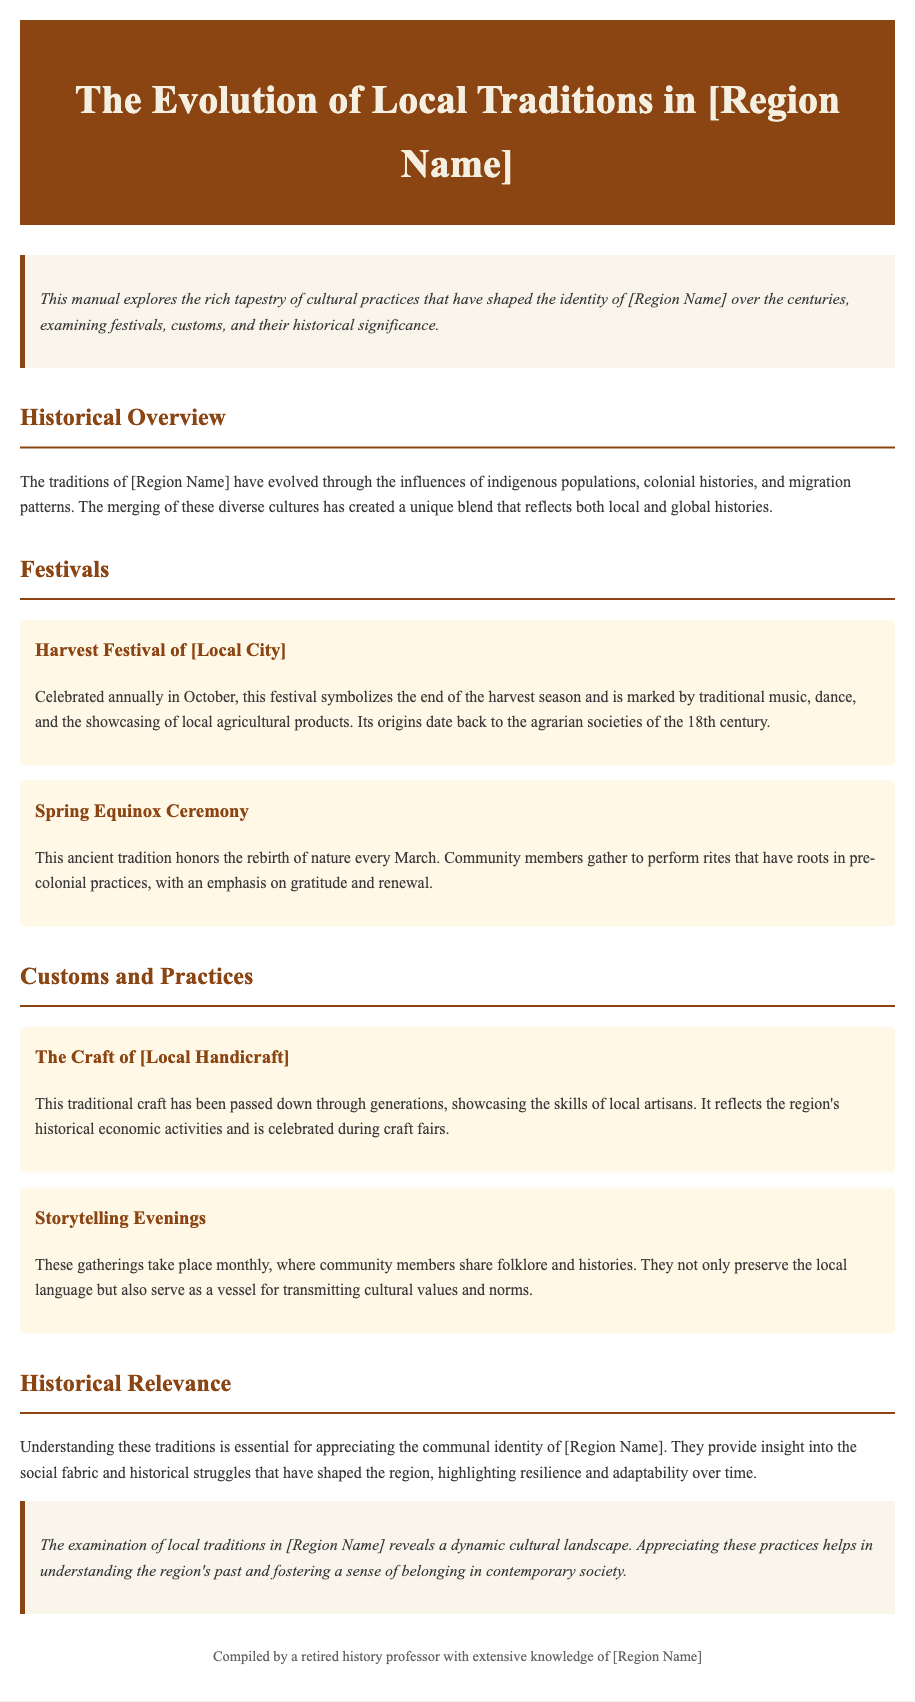What is the title of the manual? The title of the manual is found in the header section, which presents the main topic of discussion.
Answer: The Evolution of Local Traditions in [Region Name] What month is the Harvest Festival celebrated? The manual specifies that this festival takes place annually in October.
Answer: October What is the purpose of the Spring Equinox Ceremony? This ceremony has roots in pre-colonial practices and emphasizes gratitude and renewal.
Answer: Gratitude and renewal How often do Storytelling Evenings occur? The document states that these gatherings take place monthly, indicating their regularity.
Answer: Monthly What does the craft highlighted in the customs represent? The craft showcases the skills of local artisans and reflects the region's historical economic activities.
Answer: Historical economic activities What type of gatherings are mentioned in the customs section? These gatherings are aimed at preserving local folklore and transmitting cultural values and norms.
Answer: Storytelling Evenings What emphasis is placed on community in the historical relevance section? The traditions provide insight into the social fabric and historical struggles that have shaped the region, highlighting certain qualities.
Answer: Resilience and adaptability In which section is the historical overview of traditions discussed? The historical overview of traditions is covered under a dedicated section in the manual.
Answer: Historical Overview 